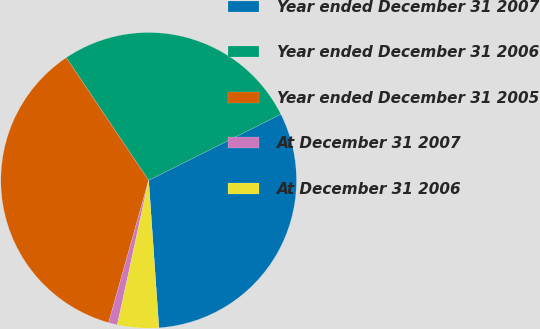Convert chart to OTSL. <chart><loc_0><loc_0><loc_500><loc_500><pie_chart><fcel>Year ended December 31 2007<fcel>Year ended December 31 2006<fcel>Year ended December 31 2005<fcel>At December 31 2007<fcel>At December 31 2006<nl><fcel>31.28%<fcel>27.03%<fcel>36.22%<fcel>0.97%<fcel>4.5%<nl></chart> 